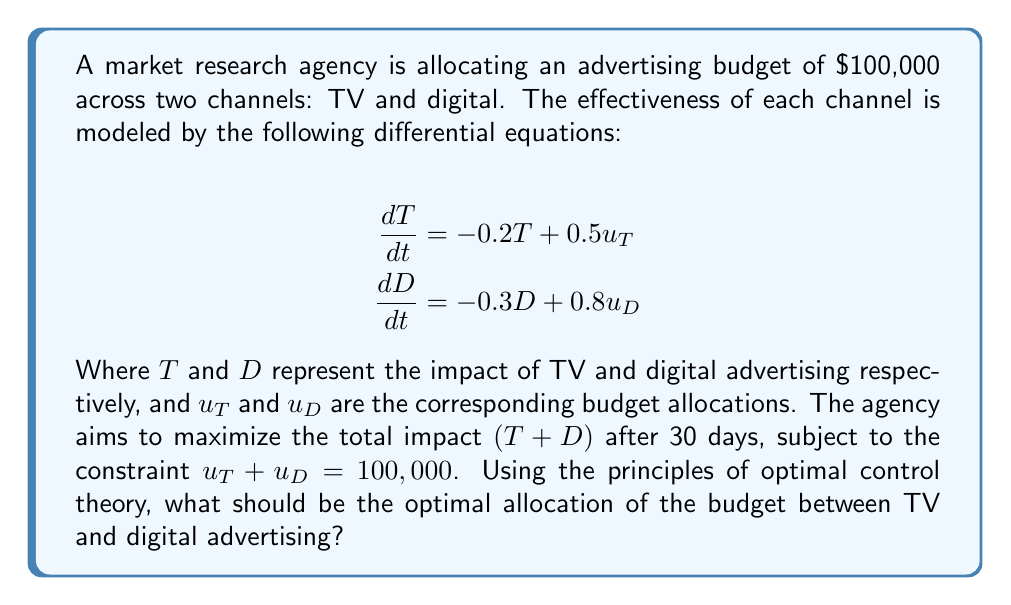What is the answer to this math problem? To solve this problem, we'll use the principles of optimal control theory:

1) First, we need to define the Hamiltonian function:
   $$H = T + D + \lambda_T(-0.2T + 0.5u_T) + \lambda_D(-0.3D + 0.8u_D)$$

2) The co-state equations are:
   $$\frac{d\lambda_T}{dt} = -\frac{\partial H}{\partial T} = -1 + 0.2\lambda_T$$
   $$\frac{d\lambda_D}{dt} = -\frac{\partial H}{\partial D} = -1 + 0.3\lambda_D$$

3) The optimal control conditions are:
   $$\frac{\partial H}{\partial u_T} = 0.5\lambda_T - \nu = 0$$
   $$\frac{\partial H}{\partial u_D} = 0.8\lambda_D - \nu = 0$$
   Where $\nu$ is the Lagrange multiplier for the budget constraint.

4) From these conditions, we can derive:
   $$0.5\lambda_T = 0.8\lambda_D$$
   $$\lambda_T = 1.6\lambda_D$$

5) Solving the co-state equations with the final condition $\lambda_T(30) = \lambda_D(30) = 1$:
   $$\lambda_T(t) = 5 - 4e^{0.2(t-30)}$$
   $$\lambda_D(t) = \frac{10}{3} - \frac{7}{3}e^{0.3(t-30)}$$

6) At $t=0$, we have:
   $$\lambda_T(0) = 5 - 4e^{-6} \approx 1.99$$
   $$\lambda_D(0) = \frac{10}{3} - \frac{7}{3}e^{-9} \approx 3.33$$

7) The ratio of budget allocation should be proportional to $\frac{\lambda_T(0)}{0.5} : \frac{\lambda_D(0)}{0.8}$, which is approximately $4.98 : 4.16$ or $1.2 : 1$.

8) Given the total budget of $100,000, the optimal allocation is:
   TV: $100,000 * \frac{1.2}{2.2} \approx 54,545$
   Digital: $100,000 * \frac{1}{2.2} \approx 45,455$
Answer: TV: $54,545, Digital: $45,455 